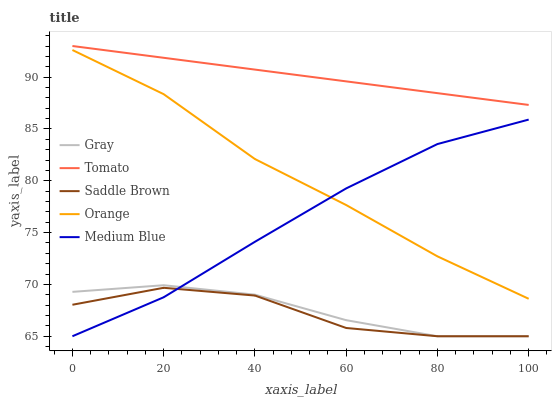Does Saddle Brown have the minimum area under the curve?
Answer yes or no. Yes. Does Tomato have the maximum area under the curve?
Answer yes or no. Yes. Does Gray have the minimum area under the curve?
Answer yes or no. No. Does Gray have the maximum area under the curve?
Answer yes or no. No. Is Tomato the smoothest?
Answer yes or no. Yes. Is Saddle Brown the roughest?
Answer yes or no. Yes. Is Gray the smoothest?
Answer yes or no. No. Is Gray the roughest?
Answer yes or no. No. Does Gray have the lowest value?
Answer yes or no. Yes. Does Orange have the lowest value?
Answer yes or no. No. Does Tomato have the highest value?
Answer yes or no. Yes. Does Gray have the highest value?
Answer yes or no. No. Is Saddle Brown less than Orange?
Answer yes or no. Yes. Is Tomato greater than Medium Blue?
Answer yes or no. Yes. Does Gray intersect Saddle Brown?
Answer yes or no. Yes. Is Gray less than Saddle Brown?
Answer yes or no. No. Is Gray greater than Saddle Brown?
Answer yes or no. No. Does Saddle Brown intersect Orange?
Answer yes or no. No. 